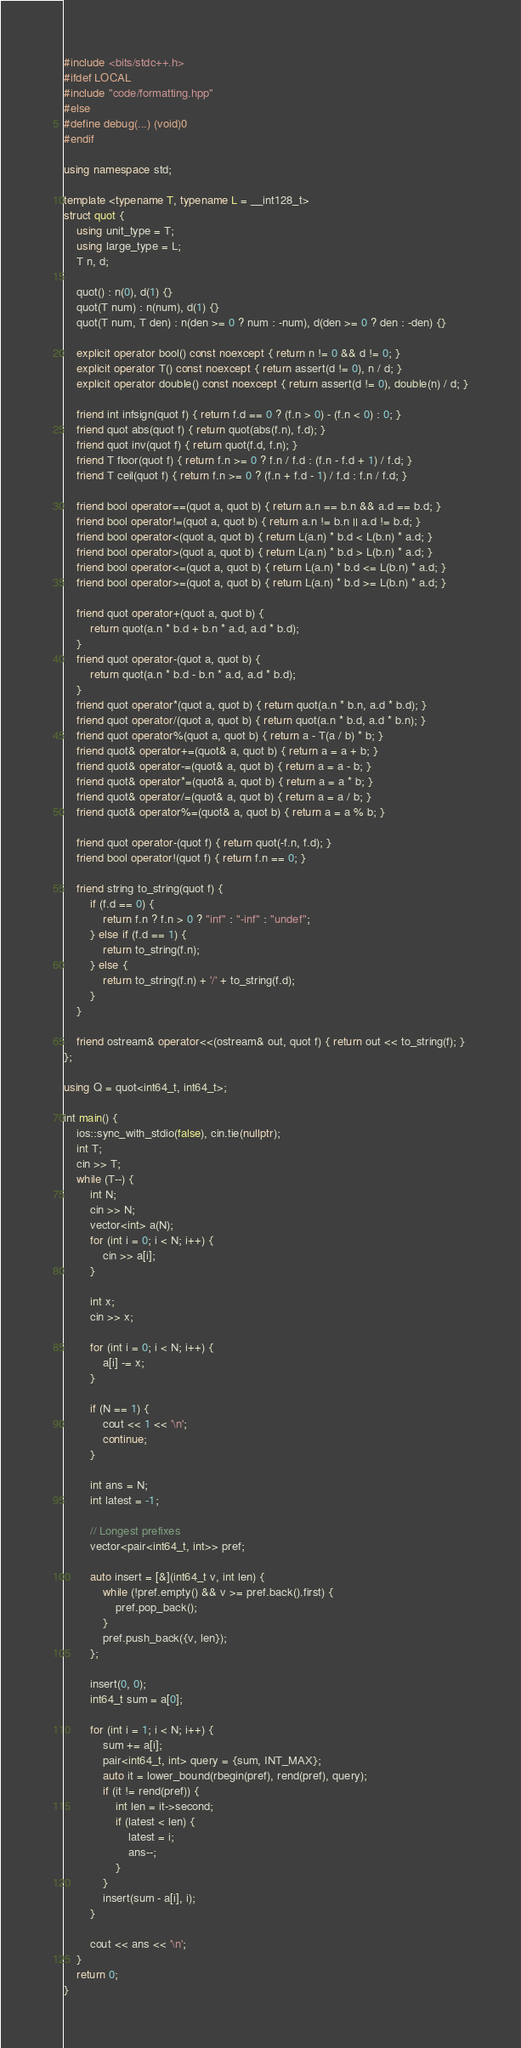<code> <loc_0><loc_0><loc_500><loc_500><_C++_>#include <bits/stdc++.h>
#ifdef LOCAL
#include "code/formatting.hpp"
#else
#define debug(...) (void)0
#endif

using namespace std;

template <typename T, typename L = __int128_t>
struct quot {
    using unit_type = T;
    using large_type = L;
    T n, d;

    quot() : n(0), d(1) {}
    quot(T num) : n(num), d(1) {}
    quot(T num, T den) : n(den >= 0 ? num : -num), d(den >= 0 ? den : -den) {}

    explicit operator bool() const noexcept { return n != 0 && d != 0; }
    explicit operator T() const noexcept { return assert(d != 0), n / d; }
    explicit operator double() const noexcept { return assert(d != 0), double(n) / d; }

    friend int infsign(quot f) { return f.d == 0 ? (f.n > 0) - (f.n < 0) : 0; }
    friend quot abs(quot f) { return quot(abs(f.n), f.d); }
    friend quot inv(quot f) { return quot(f.d, f.n); }
    friend T floor(quot f) { return f.n >= 0 ? f.n / f.d : (f.n - f.d + 1) / f.d; }
    friend T ceil(quot f) { return f.n >= 0 ? (f.n + f.d - 1) / f.d : f.n / f.d; }

    friend bool operator==(quot a, quot b) { return a.n == b.n && a.d == b.d; }
    friend bool operator!=(quot a, quot b) { return a.n != b.n || a.d != b.d; }
    friend bool operator<(quot a, quot b) { return L(a.n) * b.d < L(b.n) * a.d; }
    friend bool operator>(quot a, quot b) { return L(a.n) * b.d > L(b.n) * a.d; }
    friend bool operator<=(quot a, quot b) { return L(a.n) * b.d <= L(b.n) * a.d; }
    friend bool operator>=(quot a, quot b) { return L(a.n) * b.d >= L(b.n) * a.d; }

    friend quot operator+(quot a, quot b) {
        return quot(a.n * b.d + b.n * a.d, a.d * b.d);
    }
    friend quot operator-(quot a, quot b) {
        return quot(a.n * b.d - b.n * a.d, a.d * b.d);
    }
    friend quot operator*(quot a, quot b) { return quot(a.n * b.n, a.d * b.d); }
    friend quot operator/(quot a, quot b) { return quot(a.n * b.d, a.d * b.n); }
    friend quot operator%(quot a, quot b) { return a - T(a / b) * b; }
    friend quot& operator+=(quot& a, quot b) { return a = a + b; }
    friend quot& operator-=(quot& a, quot b) { return a = a - b; }
    friend quot& operator*=(quot& a, quot b) { return a = a * b; }
    friend quot& operator/=(quot& a, quot b) { return a = a / b; }
    friend quot& operator%=(quot& a, quot b) { return a = a % b; }

    friend quot operator-(quot f) { return quot(-f.n, f.d); }
    friend bool operator!(quot f) { return f.n == 0; }

    friend string to_string(quot f) {
        if (f.d == 0) {
            return f.n ? f.n > 0 ? "inf" : "-inf" : "undef";
        } else if (f.d == 1) {
            return to_string(f.n);
        } else {
            return to_string(f.n) + '/' + to_string(f.d);
        }
    }

    friend ostream& operator<<(ostream& out, quot f) { return out << to_string(f); }
};

using Q = quot<int64_t, int64_t>;

int main() {
    ios::sync_with_stdio(false), cin.tie(nullptr);
    int T;
    cin >> T;
    while (T--) {
        int N;
        cin >> N;
        vector<int> a(N);
        for (int i = 0; i < N; i++) {
            cin >> a[i];
        }

        int x;
        cin >> x;

        for (int i = 0; i < N; i++) {
            a[i] -= x;
        }

        if (N == 1) {
            cout << 1 << '\n';
            continue;
        }

        int ans = N;
        int latest = -1;

        // Longest prefixes
        vector<pair<int64_t, int>> pref;

        auto insert = [&](int64_t v, int len) {
            while (!pref.empty() && v >= pref.back().first) {
                pref.pop_back();
            }
            pref.push_back({v, len});
        };

        insert(0, 0);
        int64_t sum = a[0];

        for (int i = 1; i < N; i++) {
            sum += a[i];
            pair<int64_t, int> query = {sum, INT_MAX};
            auto it = lower_bound(rbegin(pref), rend(pref), query);
            if (it != rend(pref)) {
                int len = it->second;
                if (latest < len) {
                    latest = i;
                    ans--;
                }
            }
            insert(sum - a[i], i);
        }

        cout << ans << '\n';
    }
    return 0;
}
</code> 